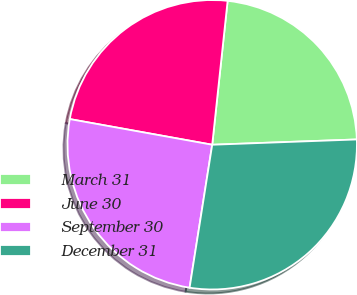Convert chart. <chart><loc_0><loc_0><loc_500><loc_500><pie_chart><fcel>March 31<fcel>June 30<fcel>September 30<fcel>December 31<nl><fcel>22.72%<fcel>23.86%<fcel>25.34%<fcel>28.08%<nl></chart> 